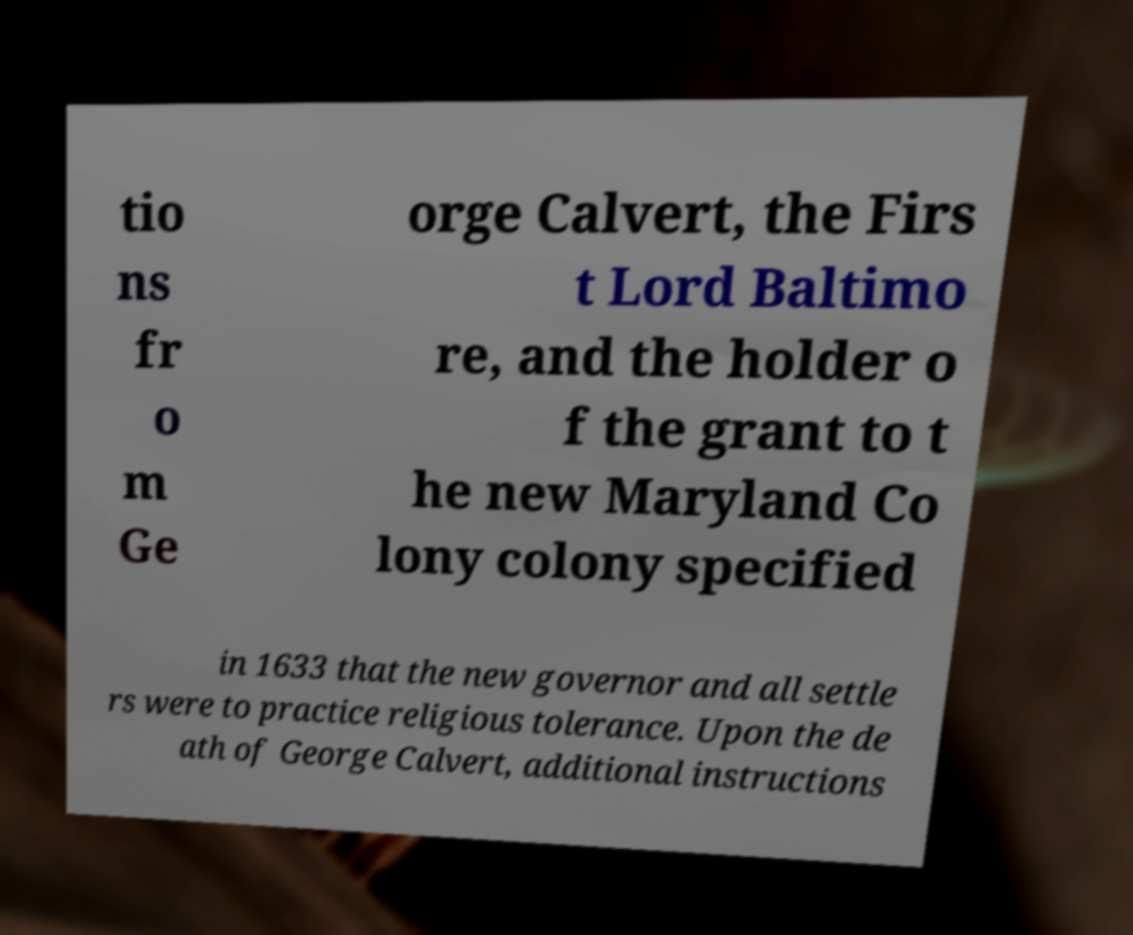Could you extract and type out the text from this image? tio ns fr o m Ge orge Calvert, the Firs t Lord Baltimo re, and the holder o f the grant to t he new Maryland Co lony colony specified in 1633 that the new governor and all settle rs were to practice religious tolerance. Upon the de ath of George Calvert, additional instructions 